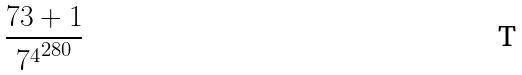<formula> <loc_0><loc_0><loc_500><loc_500>\frac { 7 3 + 1 } { { 7 ^ { 4 } } ^ { 2 8 0 } }</formula> 